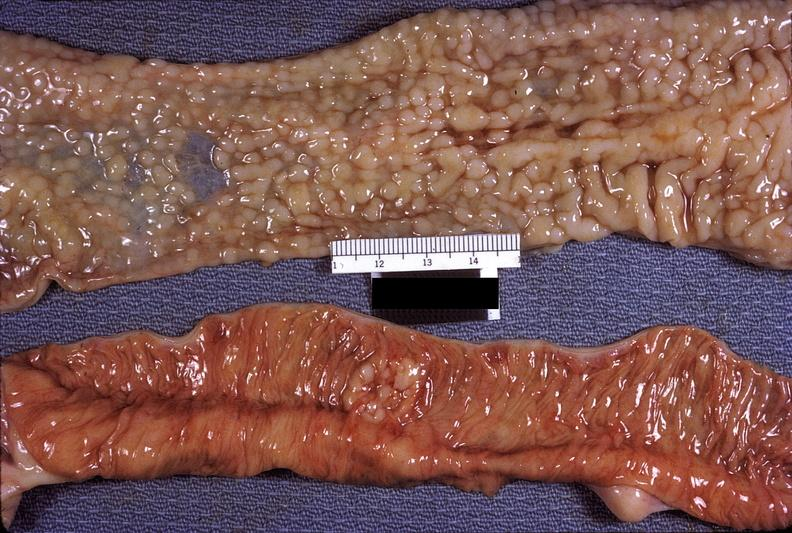where does this belong to?
Answer the question using a single word or phrase. Gastrointestinal system 